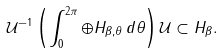<formula> <loc_0><loc_0><loc_500><loc_500>\mathcal { U } ^ { - 1 } \left ( \int ^ { 2 \pi } _ { 0 } \oplus H _ { \beta , \theta } \, d \theta \right ) \mathcal { U } \subset H _ { \beta } .</formula> 